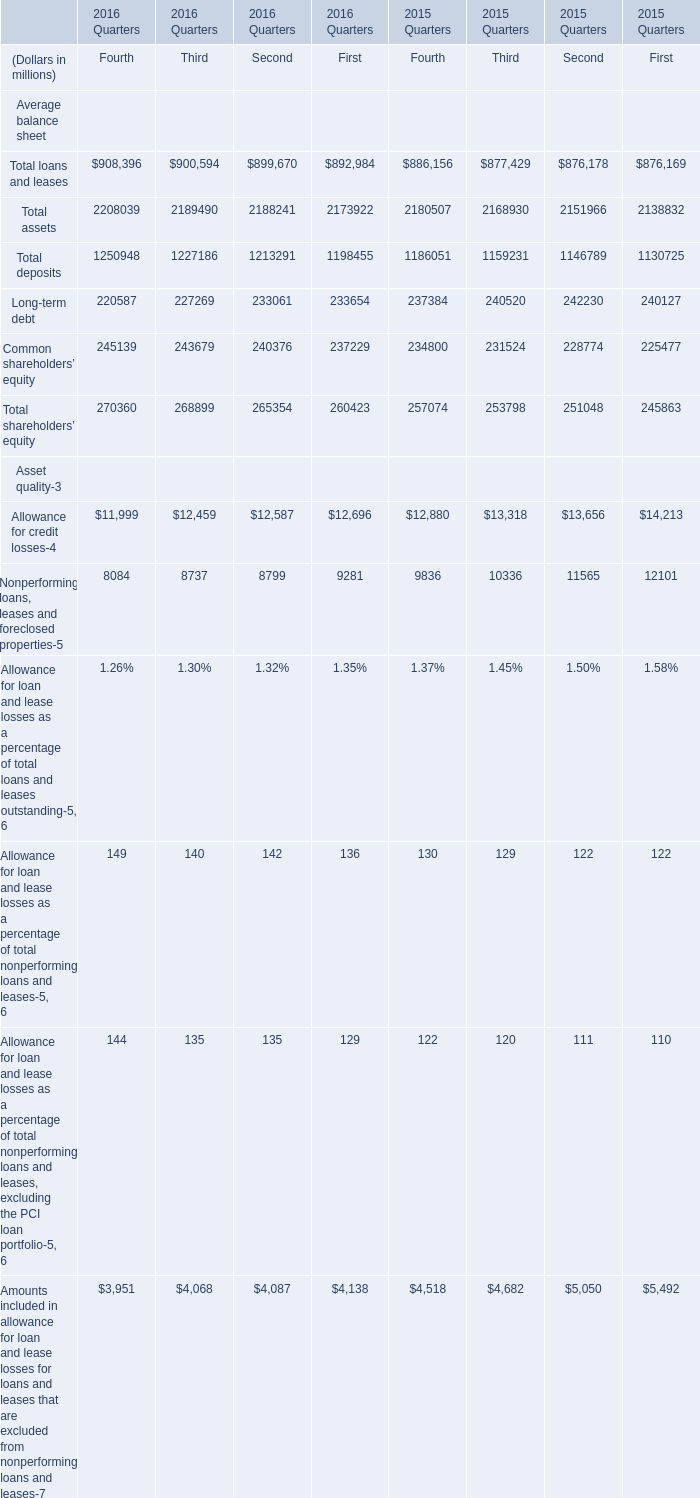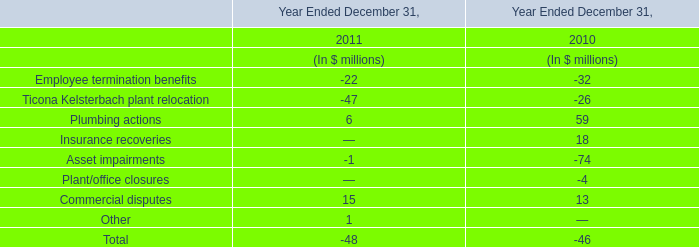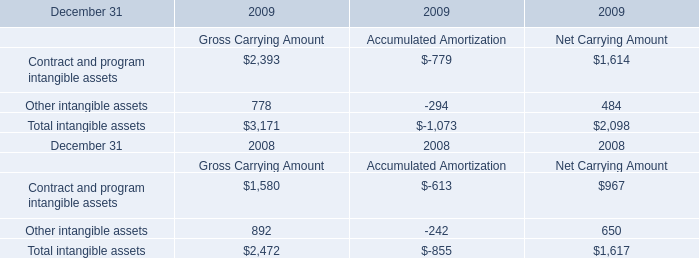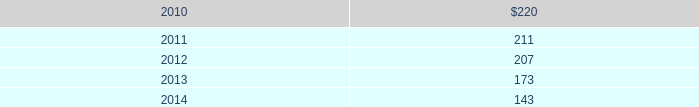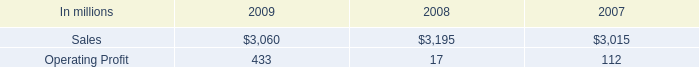north american consumer packaging net sales where what percentage of consumer packaging sales in 2009? 
Computations: ((2.2 * 1000) / 3060)
Answer: 0.71895. 